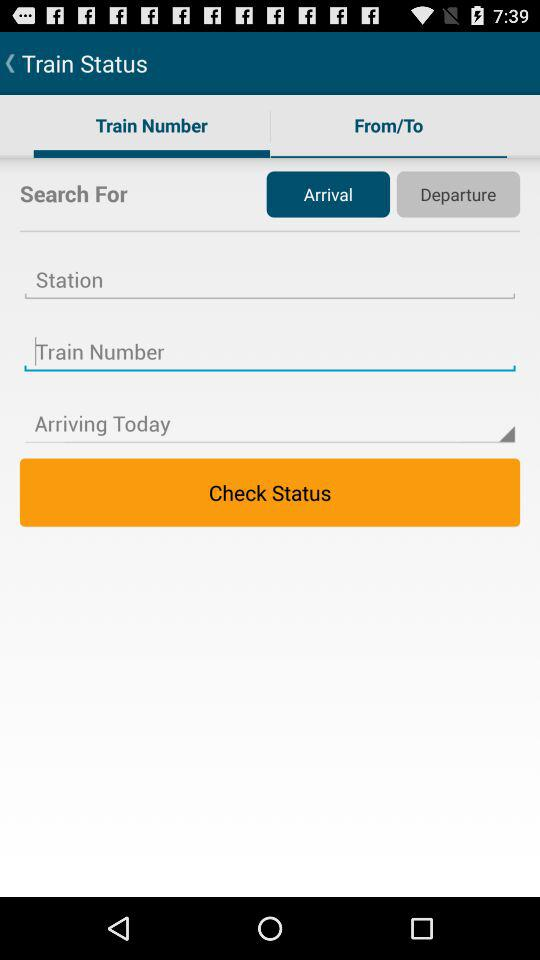Which station are we coming from?
When the provided information is insufficient, respond with <no answer>. <no answer> 